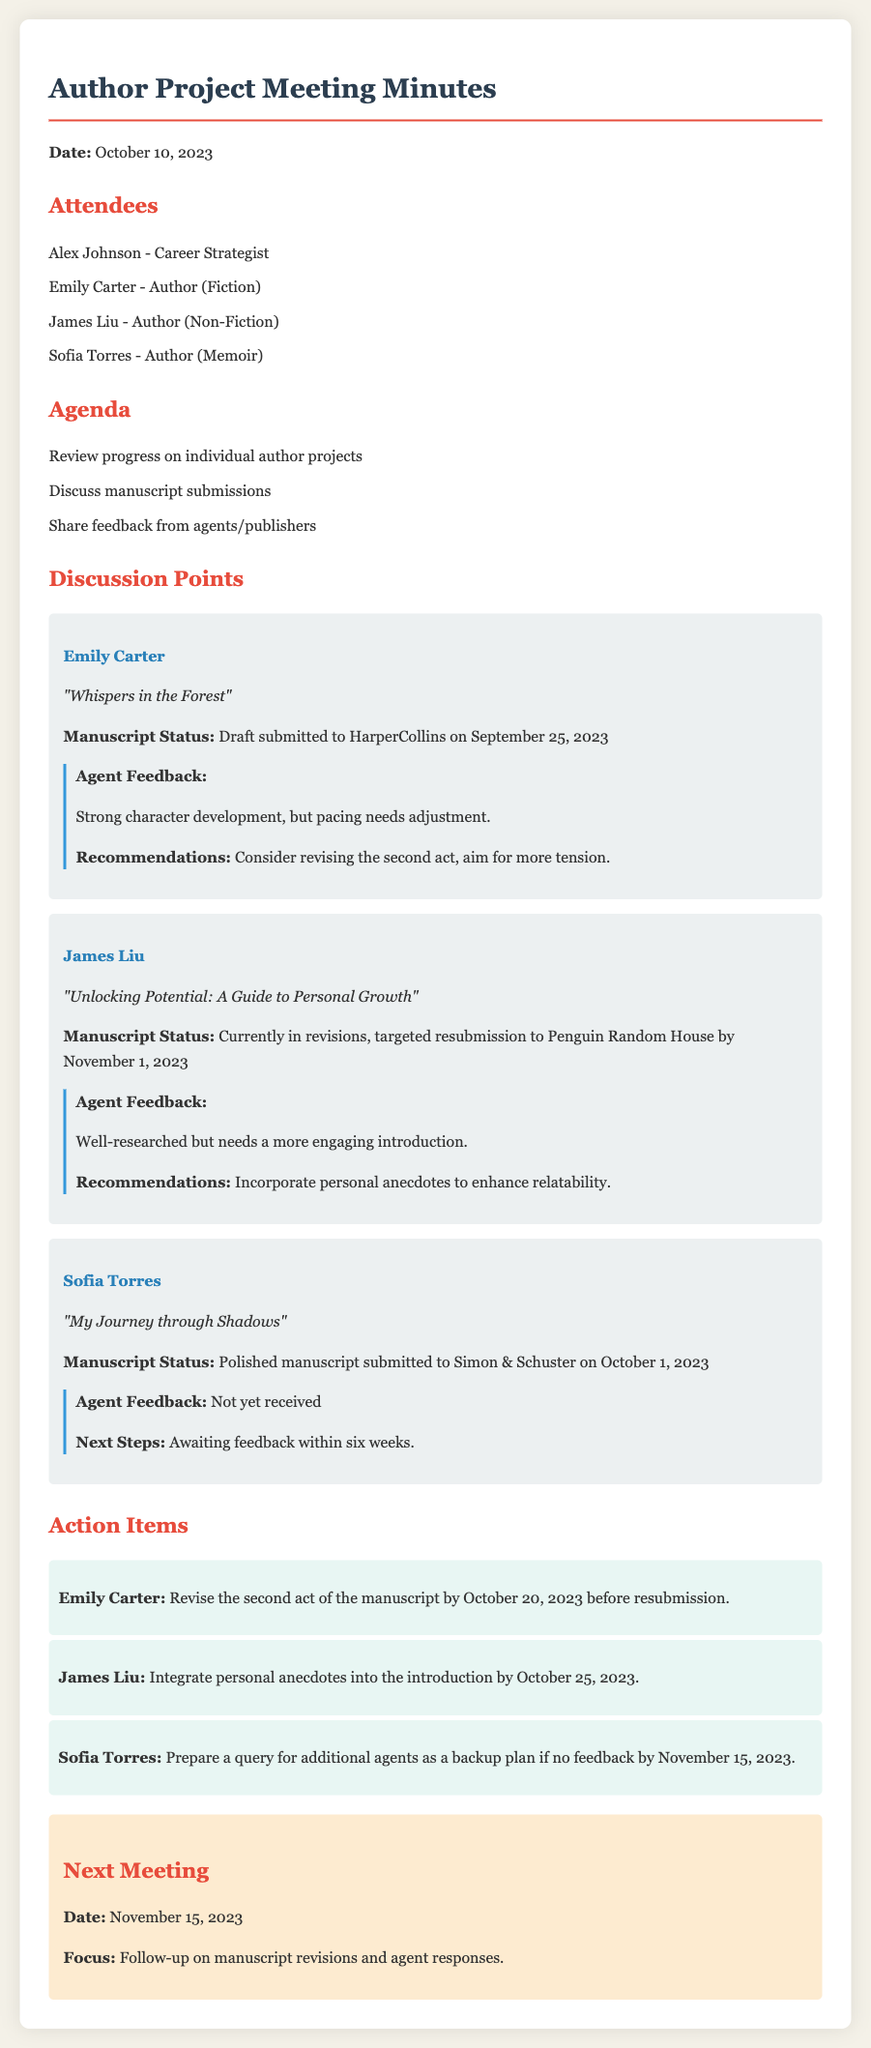What is the date of the meeting? The date of the meeting is mentioned at the beginning of the document.
Answer: October 10, 2023 Who is the author of "Whispers in the Forest"? The document lists the authors along with their project titles.
Answer: Emily Carter What is the submission date for "My Journey through Shadows"? The submission date can be found in the section reviewing Sofia's project.
Answer: October 1, 2023 What feedback did James Liu receive from his agent? The feedback is provided in the discussion points for each author.
Answer: Well-researched but needs a more engaging introduction What is the deadline for Emily Carter to revise her manuscript? The deadline for action items is clearly stated in the action items section.
Answer: October 20, 2023 How many weeks is Sofia Torres expected to wait for agent feedback? The document specifies the expected timeline for feedback in Sofia's section.
Answer: Six weeks What is the focus of the next meeting? The focus of the next meeting is mentioned in the conclusion of the minutes.
Answer: Follow-up on manuscript revisions and agent responses When is James Liu's targeted resubmission date? The targeted resubmission date is stated in James's project status.
Answer: November 1, 2023 What should Sofia Torres prepare if no feedback is received by November 15, 2023? The next steps for Sofia are outlined in her feedback section.
Answer: Prepare a query for additional agents 